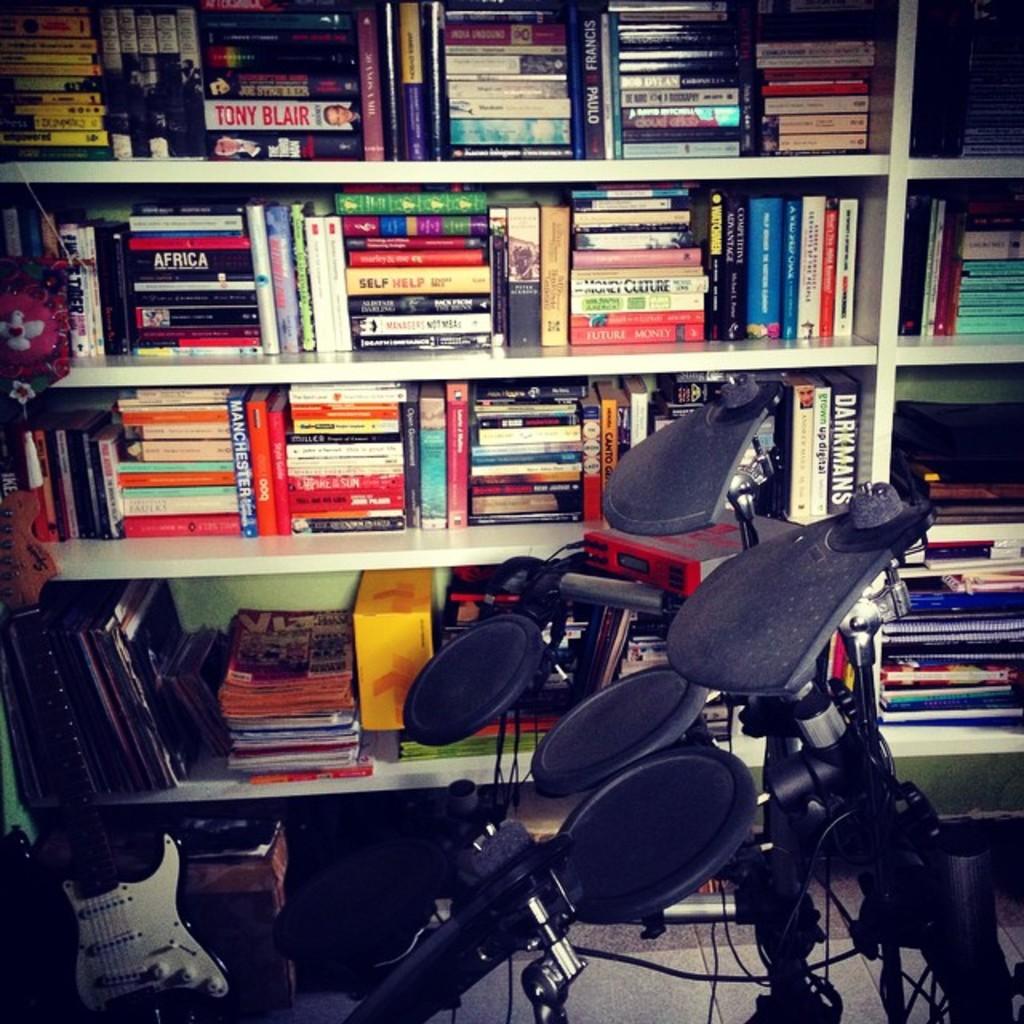What country is on the black book on the second shelf?
Your response must be concise. Africa. What is tony's last name on the book on the top?
Your answer should be very brief. Blair. 